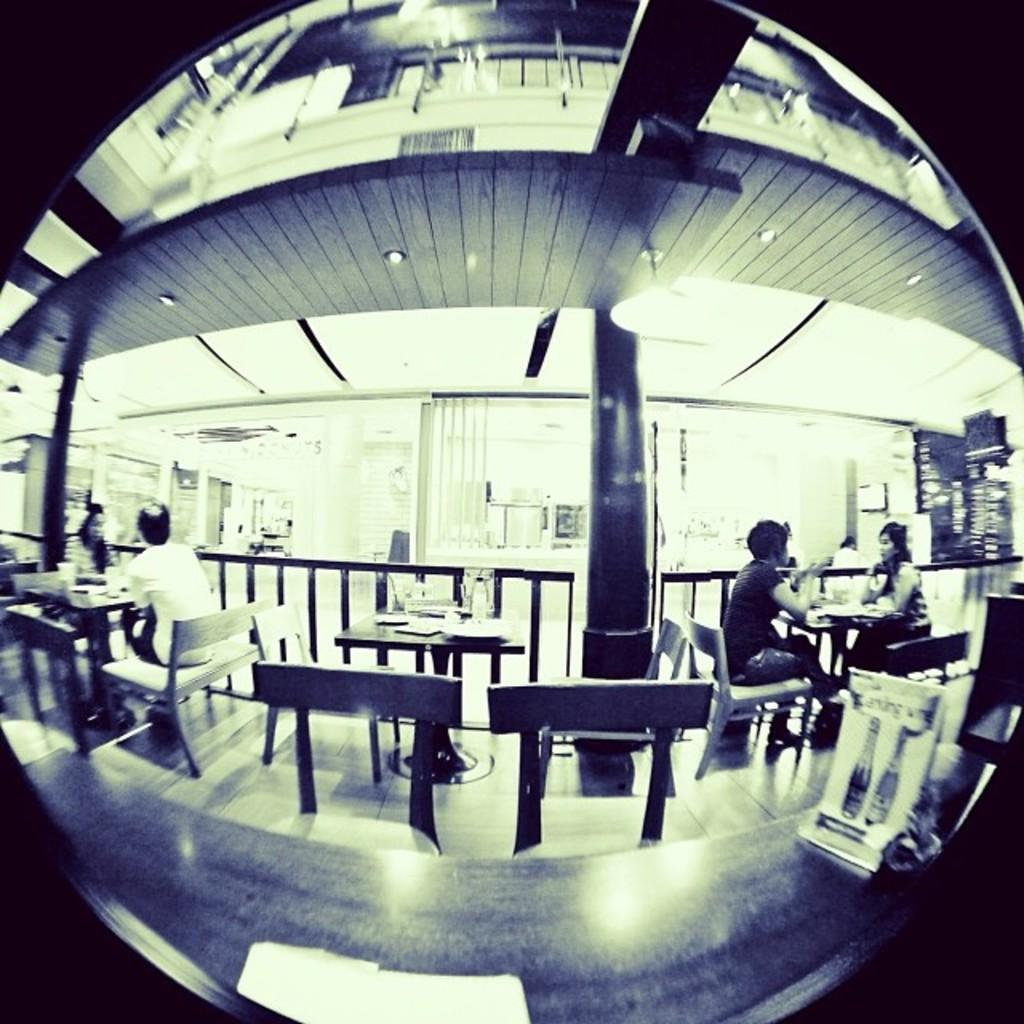What object in the image reflects the surrounding environment? There is a mirror in the image that reflects the surrounding environment. What types of furniture can be seen in the mirror? Tables and chairs are visible in the mirror. What other objects or people can be seen in the mirror? Persons, a pillar, curtains, plates, lights, and a wall are visible in the mirror. How many cherries are on the fireman's hat in the image? There is no fireman or cherries present in the image. 